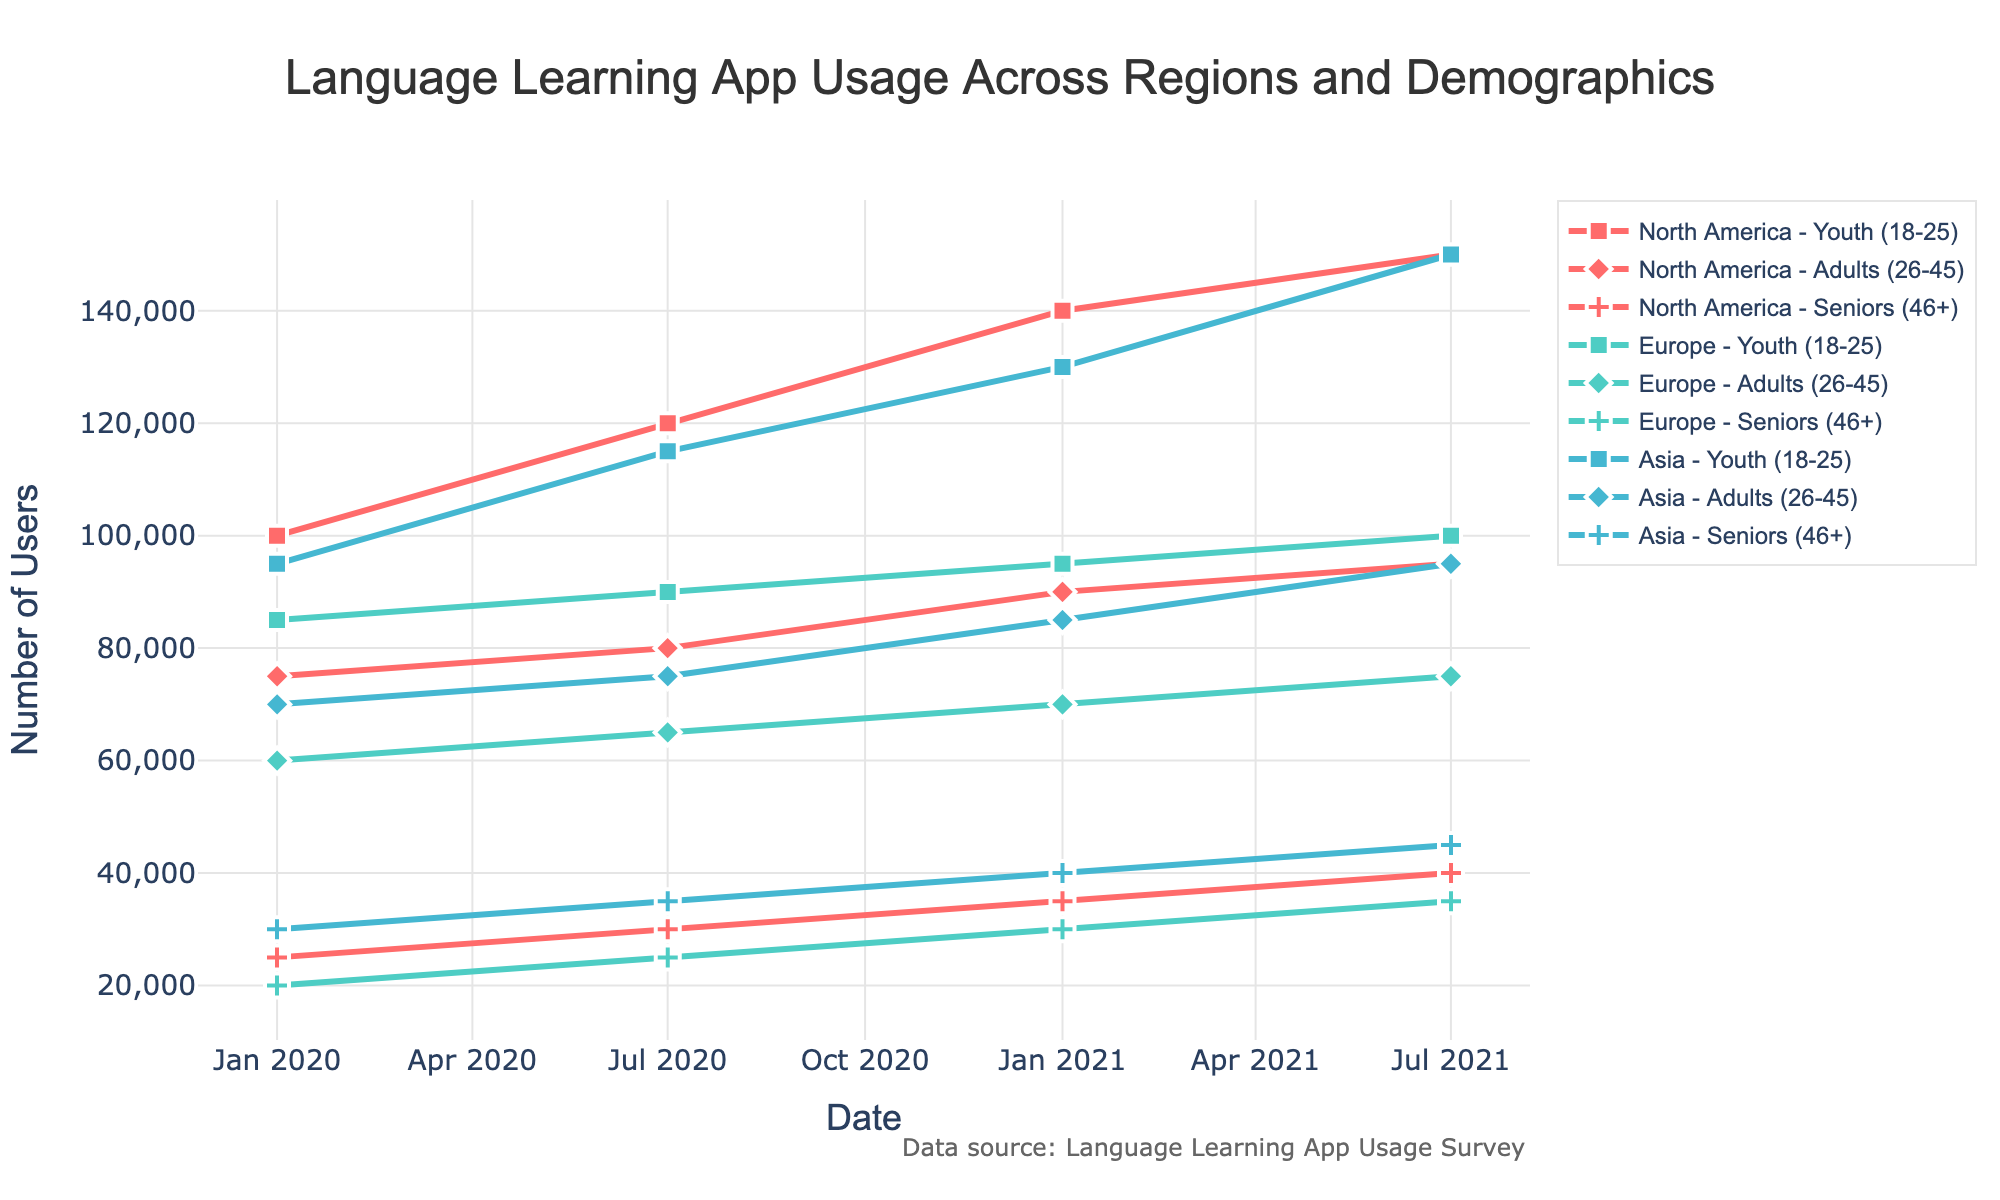What is the title of the figure? The title is usually placed at the top of the figure and describes the overall content.
Answer: Language Learning App Usage Across Regions and Demographics How many different regions are depicted in the figure? To answer this, identify the unique regions labeled in the figure.
Answer: 3 Which demographic group in Asia has the highest number of users in January 2021? Look at the user counts for each demographic in Asia for January 2021 and identify the highest one.
Answer: Youth (18-25) How did the number of users of Duolingo in North America among the Youth demographic change from January 2020 to July 2021? Compare the user counts of Duolingo in North America for the Youth demographic between January 2020 and July 2021.
Answer: Increased by 50,000 users Which region and demographic showed the largest increase in app users from January 2020 to July 2021? Calculate the difference in user counts for each combination of region and demographic between January 2020 and July 2021, and identify the largest difference.
Answer: Youth (18-25) in Asia What was the user's trend for Babbel in Europe from January 2020 to July 2021 for the Adult demographic? Identify the user counts for Babbel in the Adult demographic in Europe over the specified dates and describe the trend.
Answer: Increasing Which app had the highest number of users overall in July 2021? Sum the users for each app across all regions and demographics for July 2021 and identify the highest sum.
Answer: HelloTalk How did the number of users for the Seniors demographic in Europe for Babbel change between January 2020 and July 2021? Compare user counts for the Seniors demographic in Europe using Babbel between January 2020 and July 2021.
Answer: Increased by 15,000 users Between Duolingo in North America and HelloTalk in Asia, which app had more users among Adults in July 2021? Compare user counts between Duolingo in North America and HelloTalk in Asia for Adults in July 2021.
Answer: HelloTalk in Asia 